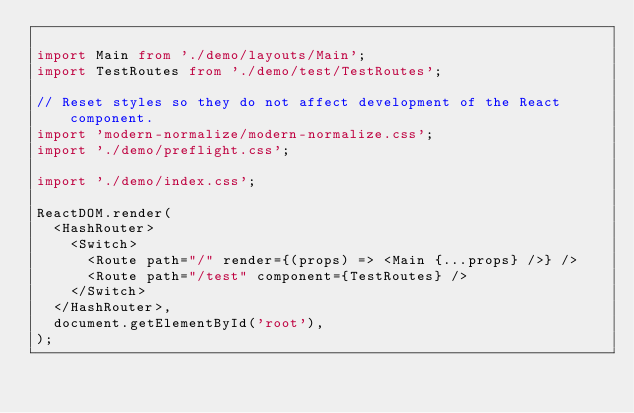<code> <loc_0><loc_0><loc_500><loc_500><_TypeScript_>
import Main from './demo/layouts/Main';
import TestRoutes from './demo/test/TestRoutes';

// Reset styles so they do not affect development of the React component.
import 'modern-normalize/modern-normalize.css';
import './demo/preflight.css';

import './demo/index.css';

ReactDOM.render(
  <HashRouter>
    <Switch>
      <Route path="/" render={(props) => <Main {...props} />} />
      <Route path="/test" component={TestRoutes} />
    </Switch>
  </HashRouter>,
  document.getElementById('root'),
);
</code> 